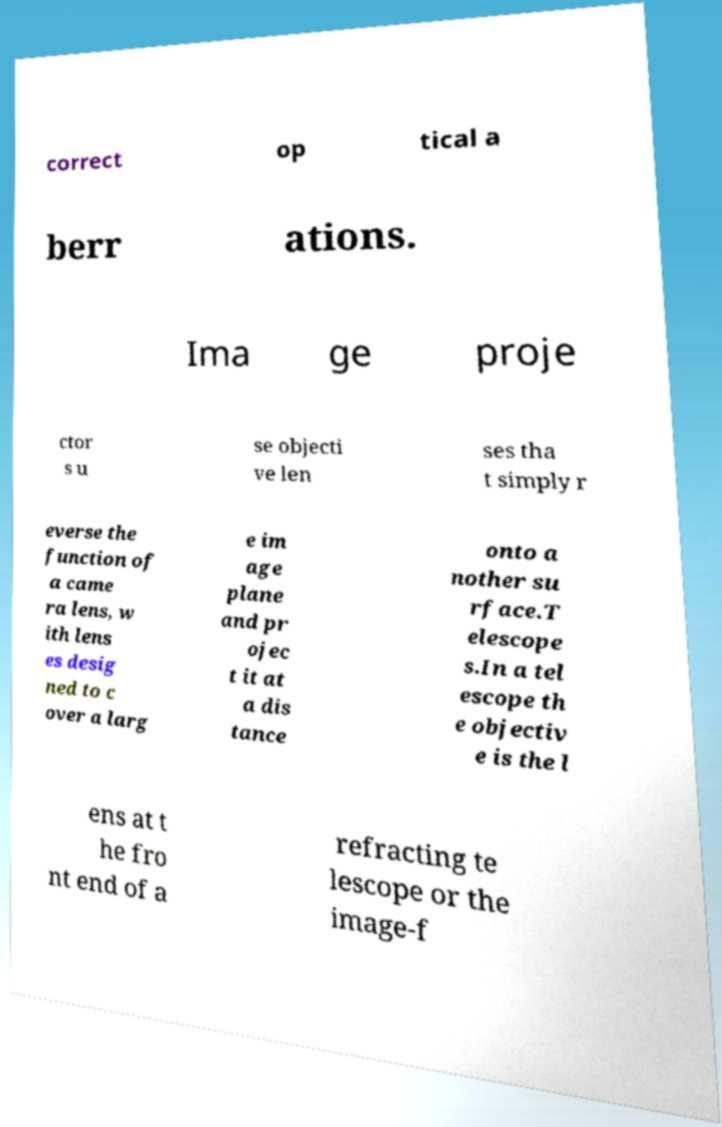Can you accurately transcribe the text from the provided image for me? correct op tical a berr ations. Ima ge proje ctor s u se objecti ve len ses tha t simply r everse the function of a came ra lens, w ith lens es desig ned to c over a larg e im age plane and pr ojec t it at a dis tance onto a nother su rface.T elescope s.In a tel escope th e objectiv e is the l ens at t he fro nt end of a refracting te lescope or the image-f 